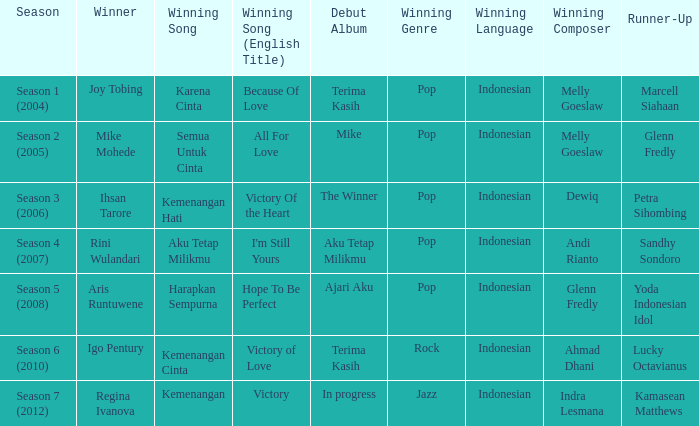Which album debuted in season 2 (2005)? Mike. 